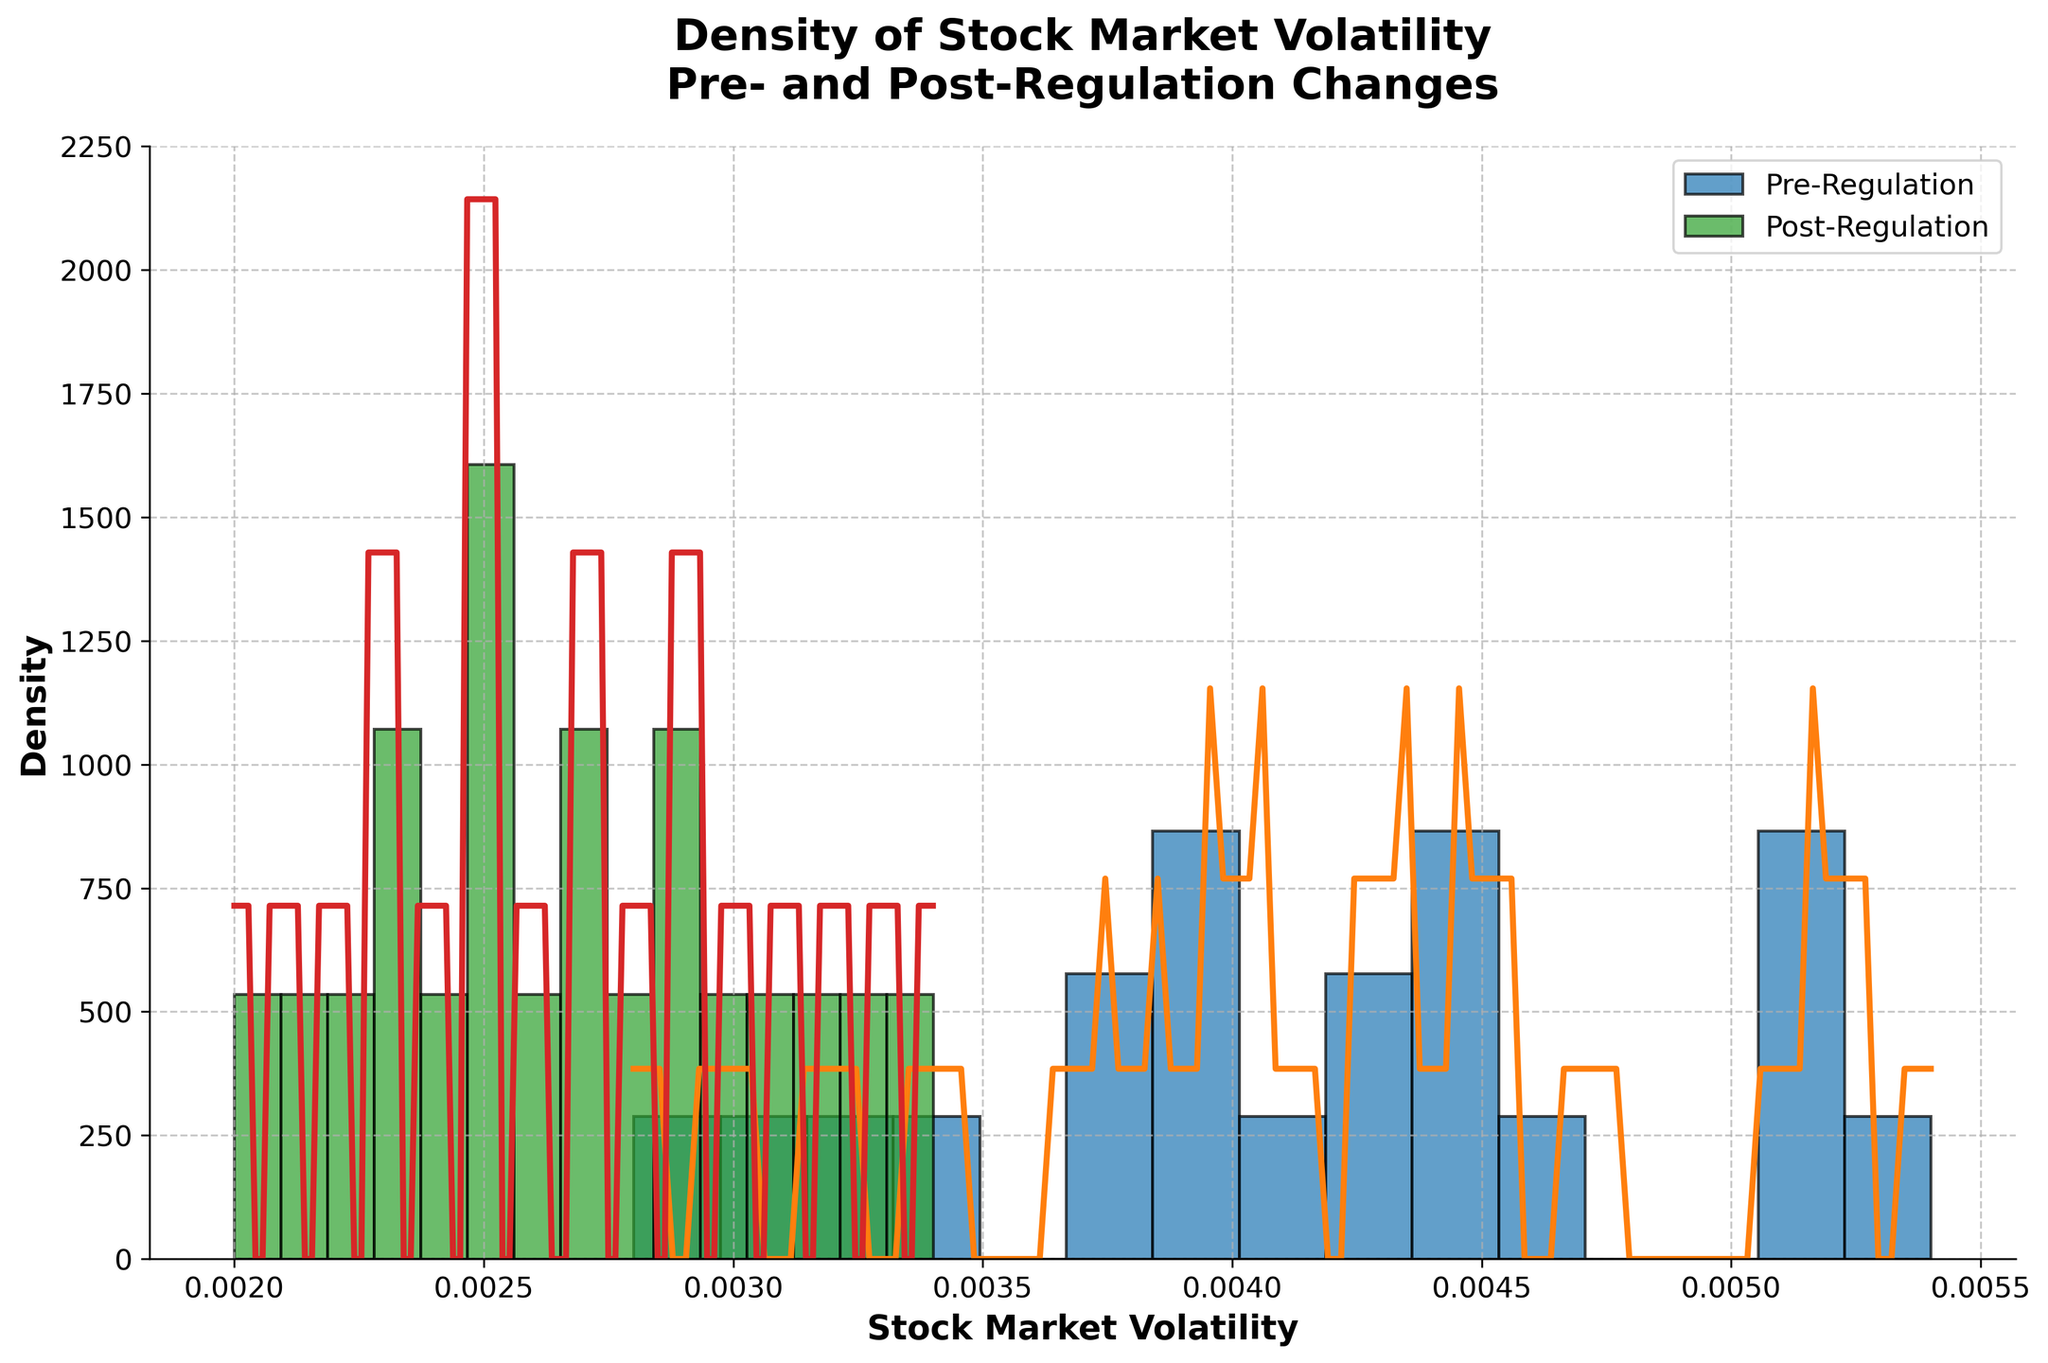What is the title of the density plot? The title of the figure is usually placed at the top and describes the topic of the plot. The title in the given plot states the subject matter clearly.
Answer: Density of Stock Market Volatility Pre- and Post-Regulation Changes Which axis represents Stock Market Volatility? In most density plots, the x-axis represents the variable being analyzed. By looking at the labels, the x-axis is marked with 'Stock Market Volatility'.
Answer: x-axis What is the range of Stock Market Volatility in the Pre-Regulation period? Observing the x-axis and the density distribution, the volatility for Pre-Regulation spans certain values. The histogram bars and density line indicate the range from approximately 0.0028 to 0.0054.
Answer: ~0.0028 to ~0.0054 How does the peak density of Post-Regulation compare to Pre-Regulation? By comparing the height of the peaks in the density lines for Pre-Regulation and Post-Regulation periods, one can observe that the peak density for Post-Regulation is higher. This suggests a higher concentration of data points around the peak for the Post-Regulation period.
Answer: Post-Regulation has a higher peak density What does the higher density in the smaller range of Stock Market Volatility for Post-Regulation suggest? A higher density in a narrow range indicates that the Post-Regulation period had lower variability with more consistent stock market volatility values centered around that range.
Answer: Lower variability and more consistent stock market volatility Were there any changes in the average stock market volatility after the regulation? The average stock market volatility can be inferred from the peak locations of the density plots. The peak for Pre-Regulation appears to be around a higher volatility value compared to the peak for Post-Regulation. This implies a decrease in the average stock market volatility post-regulation.
Answer: Decrease in average stock market volatility What is the major visible trend from the Pre-Regulation to the Post-Regulation period? Observing the density plot, the noticeable trend is a shift towards lower volatility values and higher consistency, as indicated by the narrower and higher peaks of the Post-Regulation density line.
Answer: Shift toward lower and more consistent volatility Between Pre-Regulation and Post-Regulation, which period has a wider spread in stock market volatility? The width of the distribution (from start to end) on the x-axis depicts the spread. The Pre-Regulation period shows a broader spread of volatility values indicating a wider range of volatility than the Post-Regulation period.
Answer: Pre-Regulation How would you describe the density curve shape for Post-Regulation volatility? The shape of the density curve for Post-Regulation is taller and narrower compared to the Pre-Regulation curve, indicating a higher concentration of volatility values around a central point and less variability.
Answer: Taller and narrower 